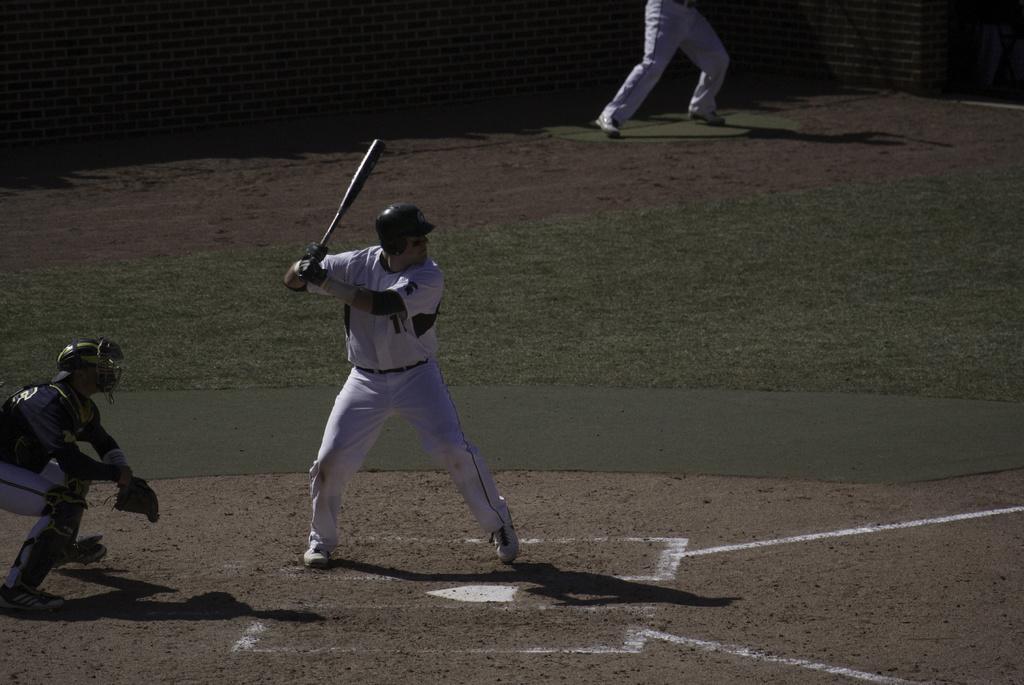Could you give a brief overview of what you see in this image? In this image we can see three persons in the ground, a person is holding a bat and a person is wearing a helmet and a wall in the background. 